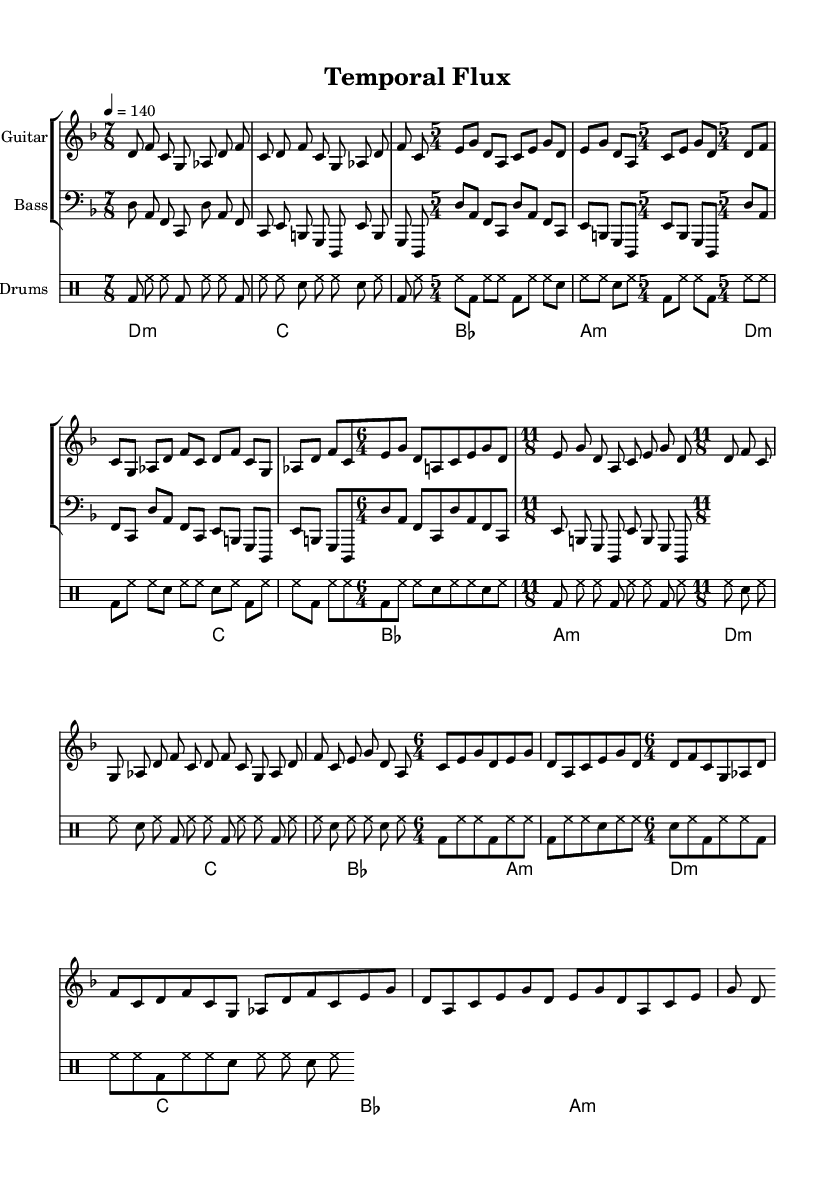What is the key signature of this music? The key signature is D minor, indicated by one flat (B flat) and the presence of D as the tonic.
Answer: D minor What is the tempo marking for this piece? The tempo marking indicates 140 beats per minute, as seen in the tempo notation at the beginning of the score.
Answer: 140 How many measures are there in the guitar part for each time signature? Since the guitar part has repetitions for each time signature, there are 2 measures for each, totaling 8 measures in total across four time signatures.
Answer: 2 measures What is the time signature used most frequently throughout this score? The time signatures provided are 7/8, 5/4, 11/8, and 6/4; however, each appears an equal number of times, so there's no single most frequent time signature, but each is used twice distinctly in different sections.
Answer: None How does the drum pattern change with time signatures in this score? The drum pattern is consistent across the time signatures, maintaining a similar rhythmical structure regardless of the change in time signature, showcasing the adaptability of the drum part.
Answer: Consistent Which instruments are indicated in the score? The instruments listed are Guitar, Bass, Drums, and Synth, which are clearly labelled in their respective staves at the beginning of the score.
Answer: Guitar, Bass, Drums, Synth How does the structure of this composition reflect the progressive metal genre? The use of unconventional time signatures like 7/8 and 11/8, combined with the extended drum solos and complex rhythms, highlights elements typical of progressive metal, emphasizing technicality and creativity.
Answer: Complex rhythms 